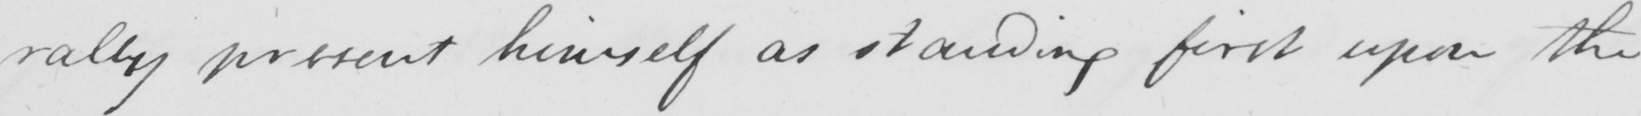What does this handwritten line say? -rally present himself as standing first upon the 